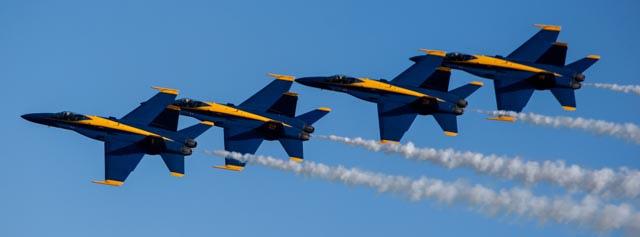How many planes are visible?
Keep it brief. 4. What are the plane's colors?
Quick response, please. Blue and yellow. What are the name of these planes?
Keep it brief. Blue angels. 